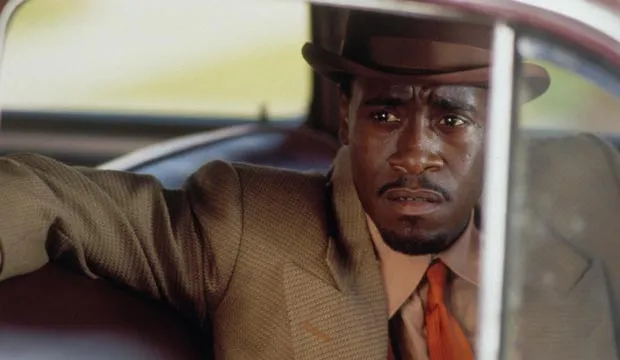Can you write a creative fictional scenario that explains why the detective looks so serious? The detective’s serious expression reflects the gravity of a secret mission he’s been given: to find and protect a key witness in a high-profile case against a notorious crime syndicate. The witness, a former accountant for the syndicate, possesses knowledge that could bring down the entire operation. As the detective waits in his car, ready for the planned rendezvous, he senses that something is off. His intuition tells him they might have been followed. The weight of the witness’ safety and the potential for explosive revelations hang heavy on him. Every shadow could conceal a threat, and he knows that a single mistake could cost them everything. Thus, his steely gaze and tense posture capture the intensity of the moment, where the balance between life and death is razor-thin. 